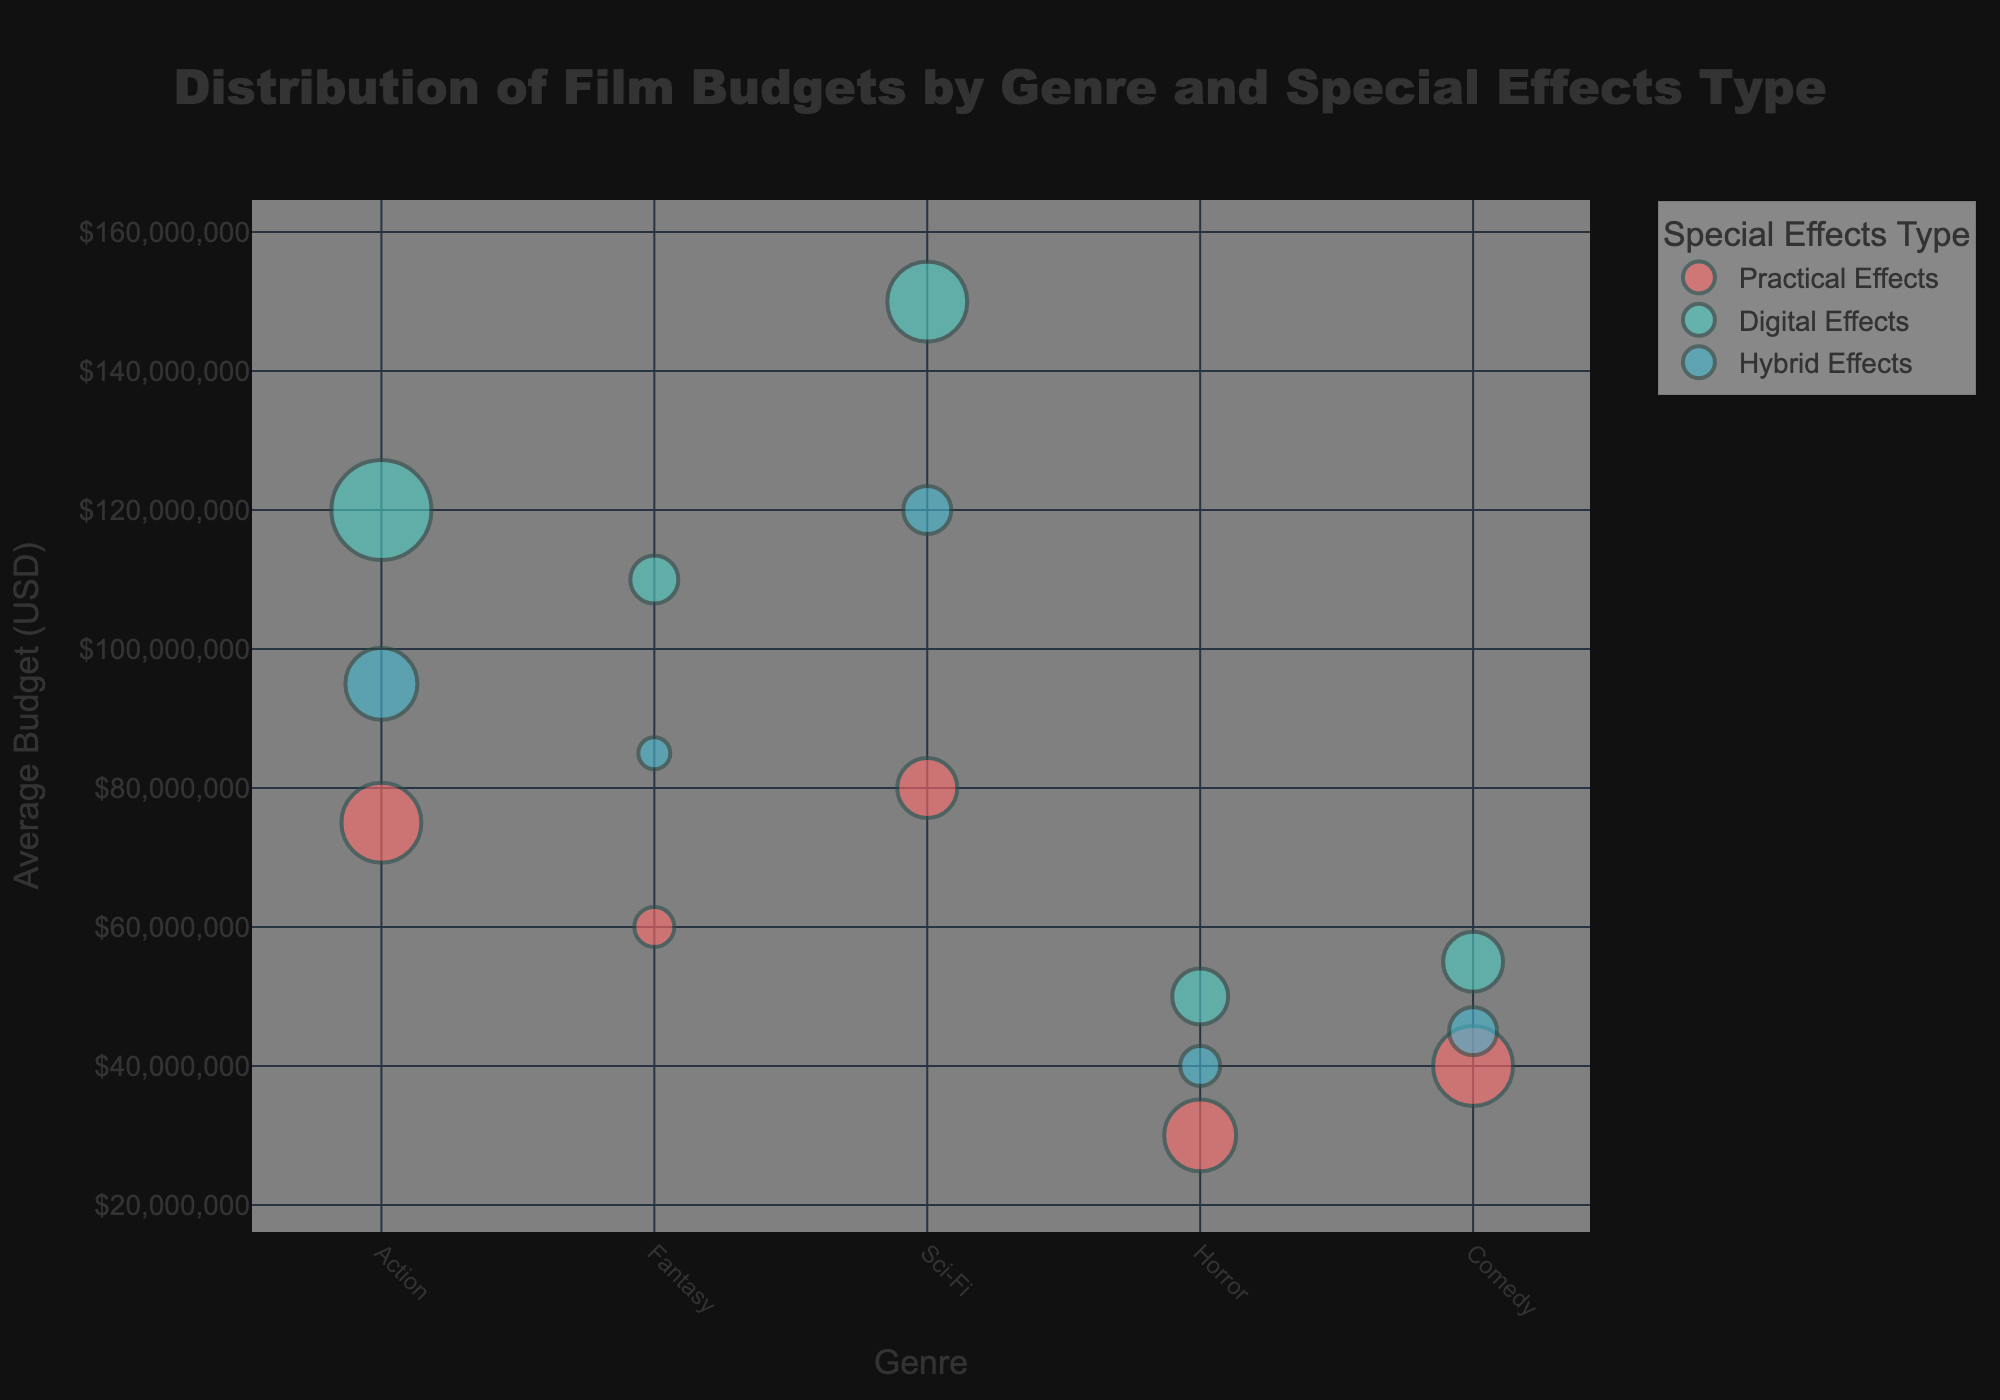How many genres are shown in the figure? There are five unique genres in the dataset: Action, Fantasy, Sci-Fi, Horror, and Comedy. You can count the distinct genres shown along the x-axis or look at the hover information in the data points.
Answer: 5 What is the title of the figure? The title of the figure is displayed at the top and is clearly labeled.
Answer: Distribution of Film Budgets by Genre and Special Effects Type Which genre has the highest average budget for Digital Effects? You need to look at the Digital Effects bubbles and compare their average budget values. The highest value corresponds to the Sci-Fi genre with an average budget of $150,000,000.
Answer: Sci-Fi What's the total number of movies for the Fantasy genre across all special effects types? Add up the total number of movies for Practical Effects (10), Digital Effects (12), and Hybrid Effects (8) under the Fantasy genre. The sum is 10 + 12 + 8 = 30.
Answer: 30 Which special effects type in Action has the largest bubble in the figure? Look at the bubbles in the Action genre and determine which has the largest size. Action genre has the largest bubble for Digital Effects with a movie count of 25.
Answer: Digital Effects What's the difference in average budget between the highest and lowest budgeted special effects types for the Horror genre? For Horror, the average budgets are $30,000,000 (Practical Effects), $50,000,000 (Digital Effects), and $40,000,000 (Hybrid Effects). The difference between the highest ($50,000,000) and lowest budget ($30,000,000) is $50,000,000 - $30,000,000.
Answer: $20,000,000 How many movie counts are there for Hybrid Effects in Comedy genre? Look at the bubble for Hybrid Effects in Comedy; the hover info reveals that the movie count is 12.
Answer: 12 Which special effects type generally has the highest average budgets across all genres? By examining the bubbles, you will notice that Digital Effects consistently have higher average budgets across most genres (e.g., Action, Fantasy, Sci-Fi).
Answer: Digital Effects Which genre has the least average budget for Practical Effects? Review the bubbles for Practical Effects and find the genre with the smallest average budget. In this case, the Horror genre has the lowest average budget at $30,000,000.
Answer: Horror What's the total average budget for Sci-Fi across all special effects types? Add the average budgets for Sci-Fi genre: $80,000,000 (Practical Effects) + $150,000,000 (Digital Effects) + $120,000,000 (Hybrid Effects). The sum is $350,000,000.
Answer: $350,000,000 